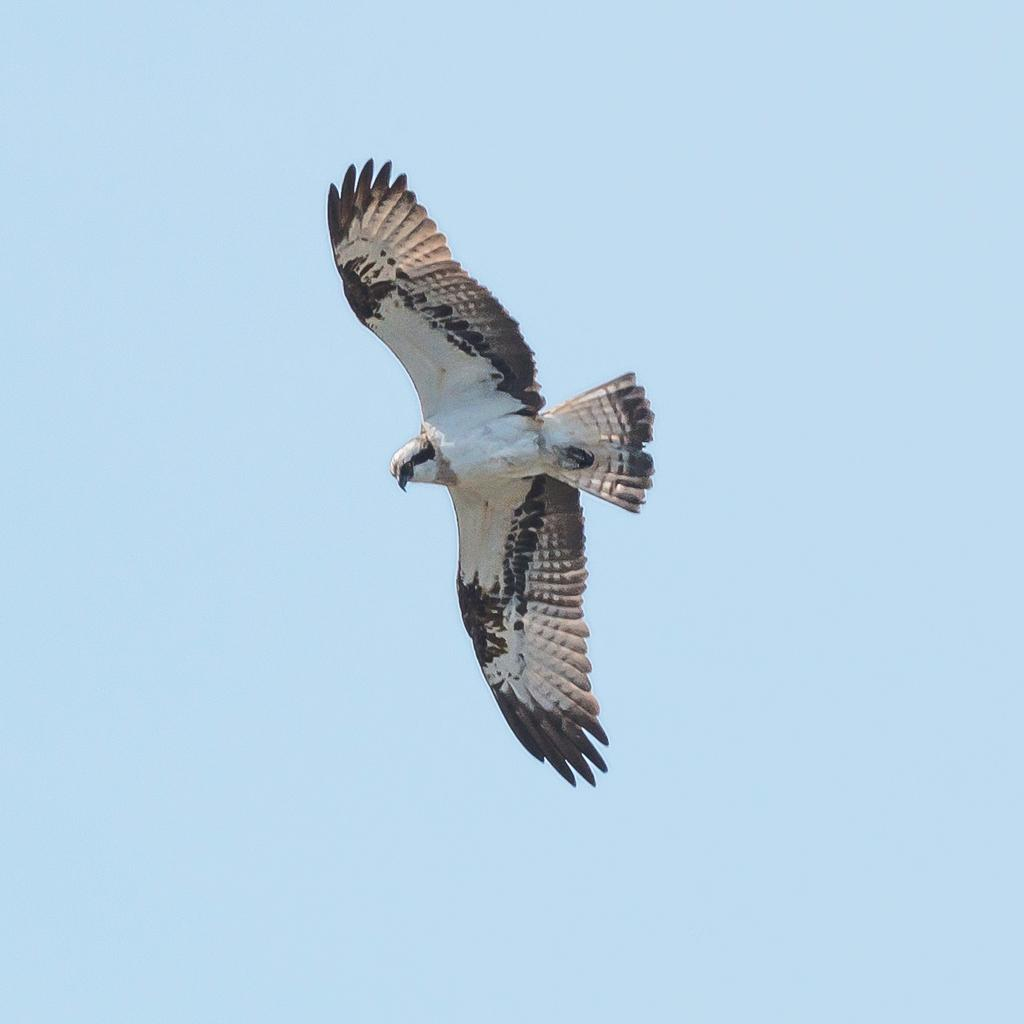What type of animal is present in the image? There is a bird in the image. What is the bird doing in the image? The bird appears to be flying. Can you describe the background of the image? The background of the image is light blue in color. Is there any indication of the bird's species in the image? The bird might be an eagle, though this is uncertain. What page is the bird turning in the image? There is no page present in the image, as it features a bird flying against a light blue background. 